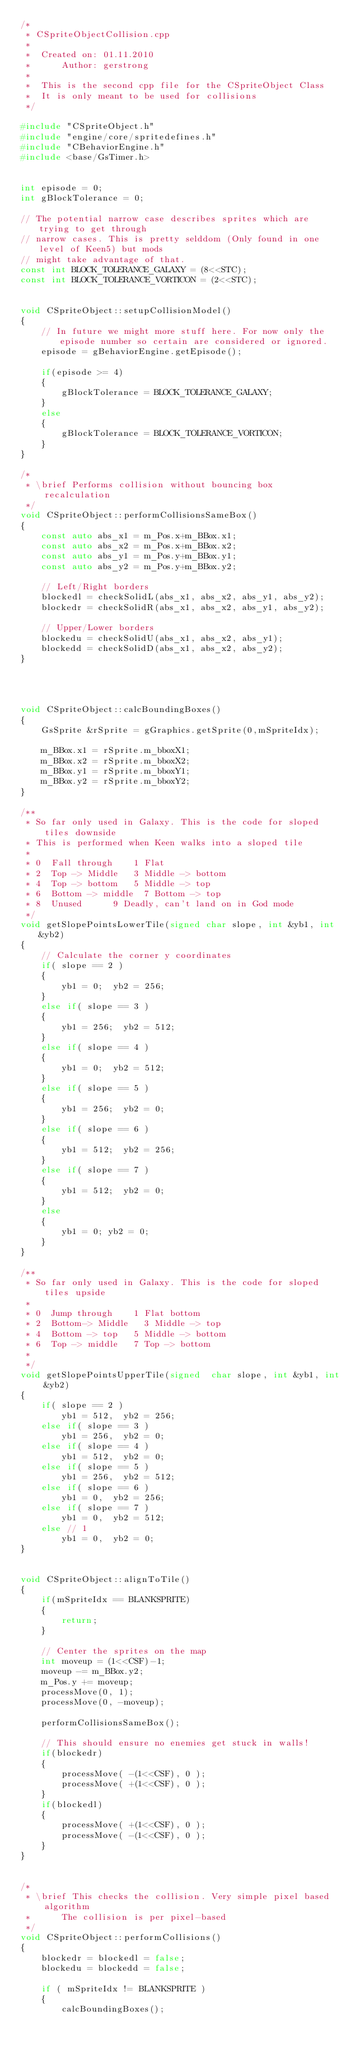<code> <loc_0><loc_0><loc_500><loc_500><_C++_>/*
 * CSpriteObjectCollision.cpp
 *
 *  Created on: 01.11.2010
 *      Author: gerstrong
 *
 *  This is the second cpp file for the CSpriteObject Class
 *  It is only meant to be used for collisions
 */

#include "CSpriteObject.h"
#include "engine/core/spritedefines.h"
#include "CBehaviorEngine.h"
#include <base/GsTimer.h>


int episode = 0;
int gBlockTolerance = 0;

// The potential narrow case describes sprites which are trying to get through
// narrow cases. This is pretty selddom (Only found in one level of Keen5) but mods
// might take advantage of that.
const int BLOCK_TOLERANCE_GALAXY = (8<<STC);
const int BLOCK_TOLERANCE_VORTICON = (2<<STC);


void CSpriteObject::setupCollisionModel()
{
    // In future we might more stuff here. For now only the episode number so certain are considered or ignored.
    episode = gBehaviorEngine.getEpisode();

    if(episode >= 4)
    {
        gBlockTolerance = BLOCK_TOLERANCE_GALAXY;
    }
    else
    {
        gBlockTolerance = BLOCK_TOLERANCE_VORTICON;
    }
}

/*
 * \brief Performs collision without bouncing box recalculation
 */
void CSpriteObject::performCollisionsSameBox()
{
    const auto abs_x1 = m_Pos.x+m_BBox.x1;
    const auto abs_x2 = m_Pos.x+m_BBox.x2;
    const auto abs_y1 = m_Pos.y+m_BBox.y1;
    const auto abs_y2 = m_Pos.y+m_BBox.y2;

    // Left/Right borders
    blockedl = checkSolidL(abs_x1, abs_x2, abs_y1, abs_y2);
    blockedr = checkSolidR(abs_x1, abs_x2, abs_y1, abs_y2);

    // Upper/Lower borders
    blockedu = checkSolidU(abs_x1, abs_x2, abs_y1);
    blockedd = checkSolidD(abs_x1, abs_x2, abs_y2);
}




void CSpriteObject::calcBoundingBoxes()
{
    GsSprite &rSprite = gGraphics.getSprite(0,mSpriteIdx);

    m_BBox.x1 = rSprite.m_bboxX1;
    m_BBox.x2 = rSprite.m_bboxX2;
    m_BBox.y1 = rSprite.m_bboxY1;
    m_BBox.y2 = rSprite.m_bboxY2;
}

/**
 * So far only used in Galaxy. This is the code for sloped tiles downside
 * This is performed when Keen walks into a sloped tile
 *
 * 0	Fall through		1	Flat
 * 2	Top -> Middle		3	Middle -> bottom
 * 4	Top -> bottom		5	Middle -> top
 * 6	Bottom -> middle	7	Bottom -> top
 * 8	Unused			9	Deadly, can't land on in God mode
 */
void getSlopePointsLowerTile(signed char slope, int &yb1, int &yb2)
{
    // Calculate the corner y coordinates
    if( slope == 2 )
    {
        yb1 = 0;	yb2 = 256;
    }
    else if( slope == 3 )
    {
        yb1 = 256;	yb2 = 512;
    }
    else if( slope == 4 )
    {
        yb1 = 0;	yb2 = 512;
    }
    else if( slope == 5 )
    {
        yb1 = 256;	yb2 = 0;
    }
    else if( slope == 6 )
    {
        yb1 = 512;	yb2 = 256;
    }
    else if( slope == 7 )
    {
        yb1 = 512;	yb2 = 0;
    }
    else
    {
        yb1 = 0; yb2 = 0;
    }
}

/**
 * So far only used in Galaxy. This is the code for sloped tiles upside
 *
 * 0	Jump through		1	Flat bottom
 * 2	Bottom-> Middle		3	Middle -> top
 * 4	Bottom -> top		5	Middle -> bottom
 * 6	Top -> middle		7	Top -> bottom
 *
 */
void getSlopePointsUpperTile(signed  char slope, int &yb1, int &yb2)
{
    if( slope == 2 )
        yb1 = 512,	yb2 = 256;
    else if( slope == 3 )
        yb1 = 256,	yb2 = 0;
    else if( slope == 4 )
        yb1 = 512,	yb2 = 0;
    else if( slope == 5 )
        yb1 = 256,	yb2 = 512;
    else if( slope == 6 )
        yb1 = 0,	yb2 = 256;
    else if( slope == 7 )
        yb1 = 0,	yb2 = 512;
    else // 1
        yb1 = 0,	yb2 = 0;
}


void CSpriteObject::alignToTile()
{
    if(mSpriteIdx == BLANKSPRITE)
    {
        return;
    }

    // Center the sprites on the map
    int moveup = (1<<CSF)-1;
    moveup -= m_BBox.y2;
    m_Pos.y += moveup;
    processMove(0, 1);
    processMove(0, -moveup);

    performCollisionsSameBox();

    // This should ensure no enemies get stuck in walls!
    if(blockedr)
    {
        processMove( -(1<<CSF), 0 );
        processMove( +(1<<CSF), 0 );
    }
    if(blockedl)
    {
        processMove( +(1<<CSF), 0 );
        processMove( -(1<<CSF), 0 );
    }
}


/*
 * \brief This checks the collision. Very simple pixel based algorithm
 * 		  The collision is per pixel-based
 */
void CSpriteObject::performCollisions()
{
    blockedr = blockedl = false;
    blockedu = blockedd = false;

    if ( mSpriteIdx != BLANKSPRITE )
    {
        calcBoundingBoxes();</code> 